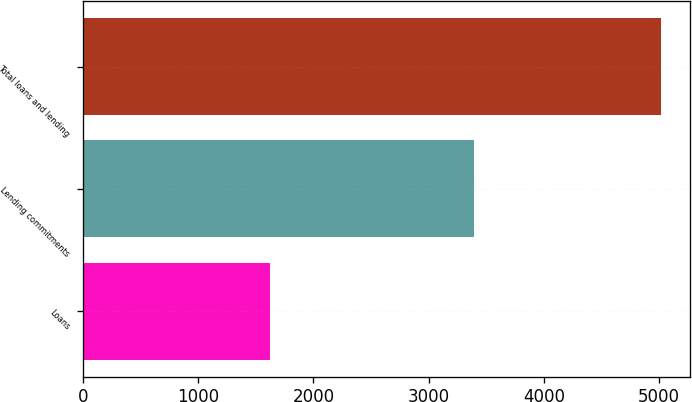<chart> <loc_0><loc_0><loc_500><loc_500><bar_chart><fcel>Loans<fcel>Lending commitments<fcel>Total loans and lending<nl><fcel>1622<fcel>3391<fcel>5013<nl></chart> 